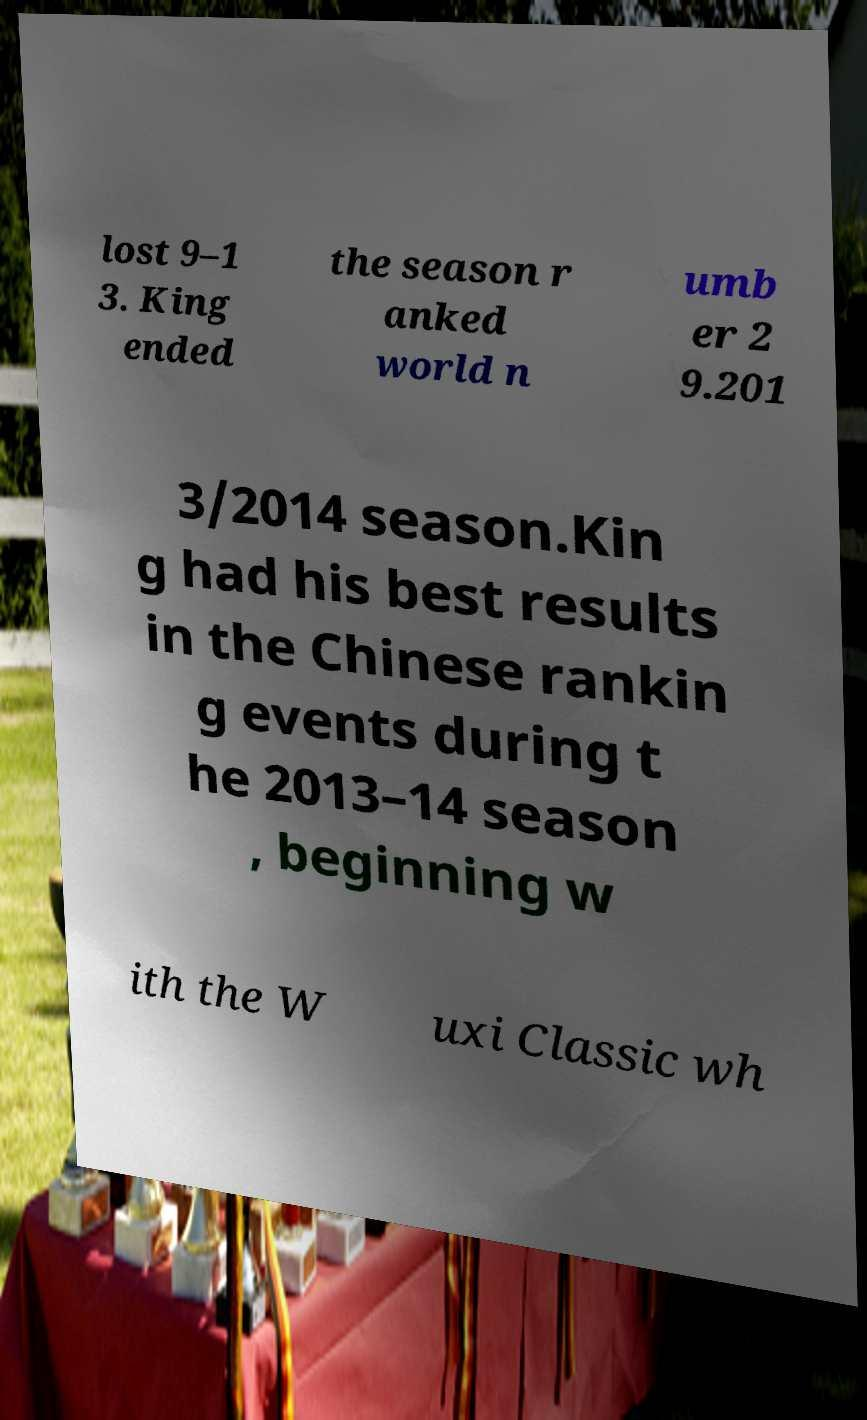Can you read and provide the text displayed in the image?This photo seems to have some interesting text. Can you extract and type it out for me? lost 9–1 3. King ended the season r anked world n umb er 2 9.201 3/2014 season.Kin g had his best results in the Chinese rankin g events during t he 2013–14 season , beginning w ith the W uxi Classic wh 